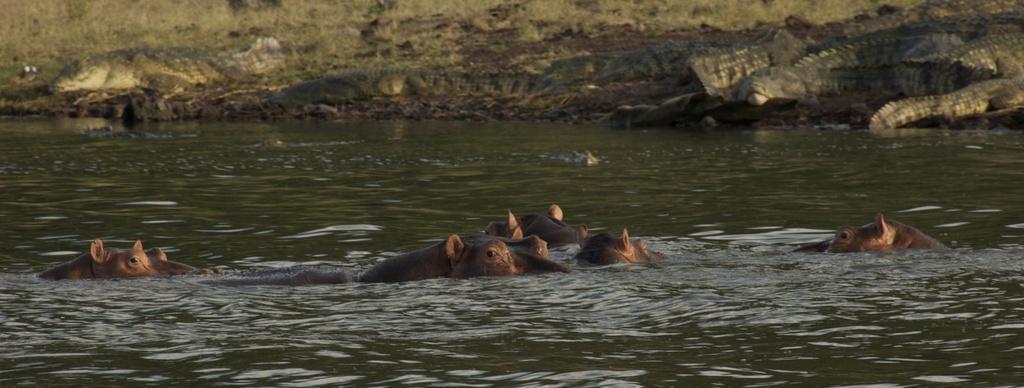In one or two sentences, can you explain what this image depicts? In this image we can see few animals in the water and in the background there are few animals on the ground looks like crocodiles. 